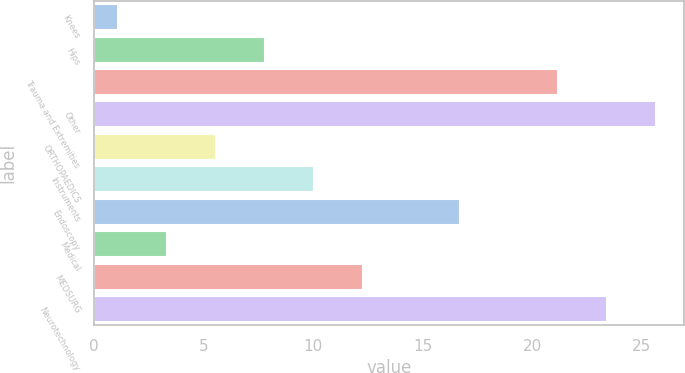<chart> <loc_0><loc_0><loc_500><loc_500><bar_chart><fcel>Knees<fcel>Hips<fcel>Trauma and Extremities<fcel>Other<fcel>ORTHOPAEDICS<fcel>Instruments<fcel>Endoscopy<fcel>Medical<fcel>MEDSURG<fcel>Neurotechnology<nl><fcel>1.1<fcel>7.79<fcel>21.17<fcel>25.63<fcel>5.56<fcel>10.02<fcel>16.71<fcel>3.33<fcel>12.25<fcel>23.4<nl></chart> 